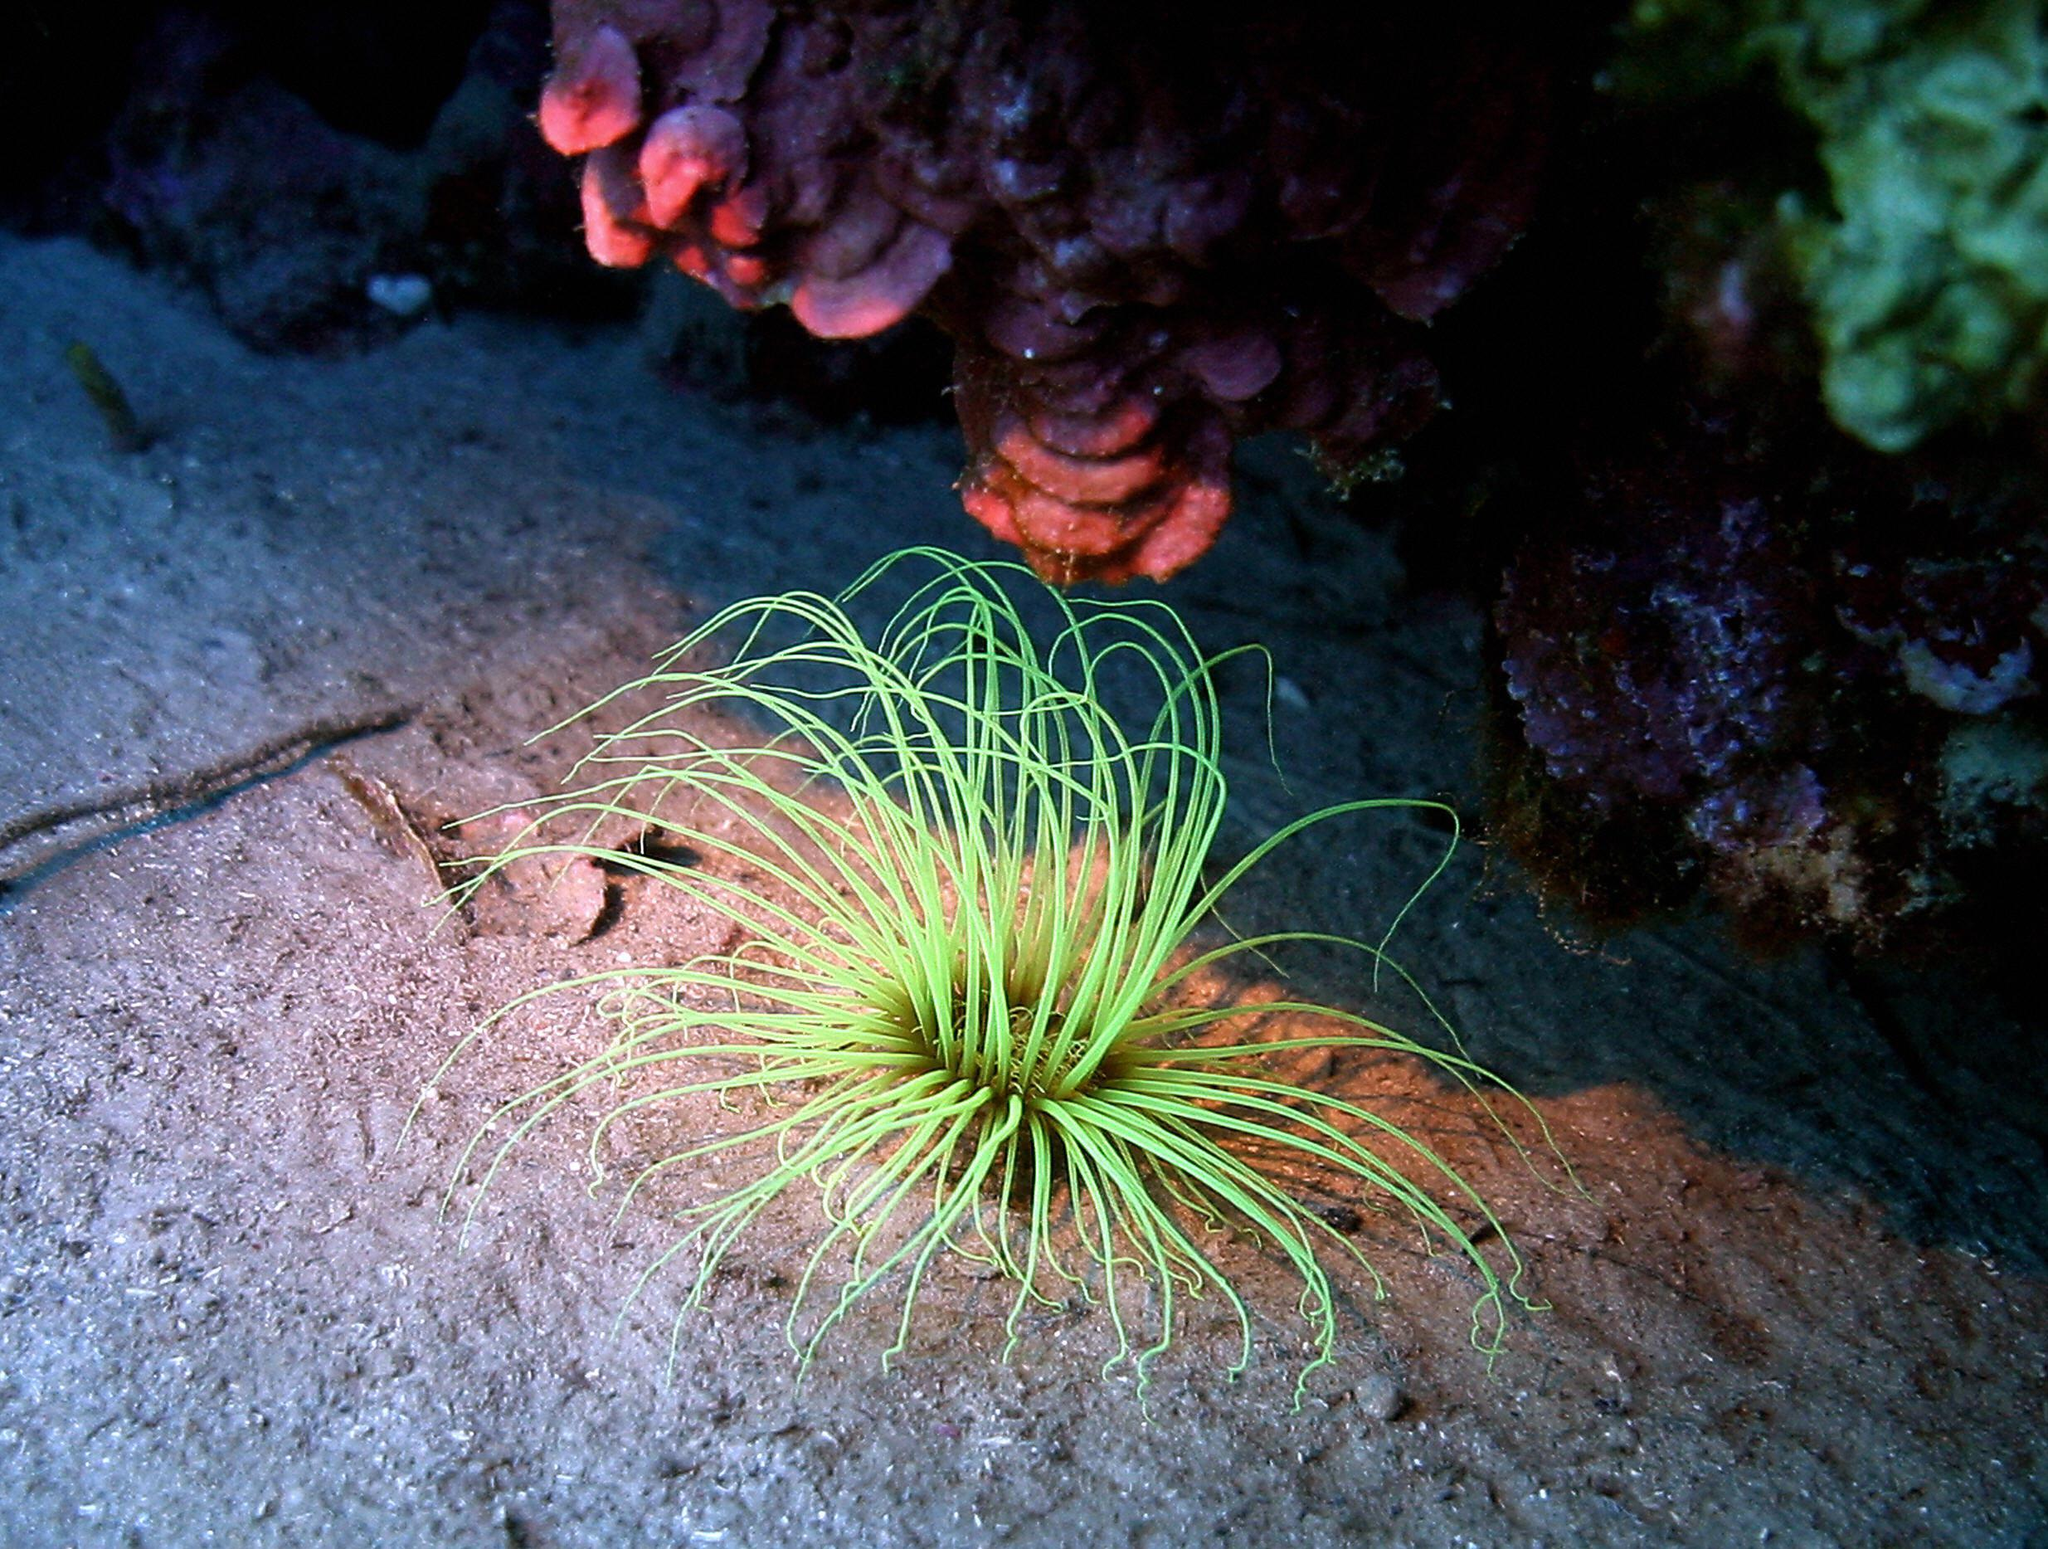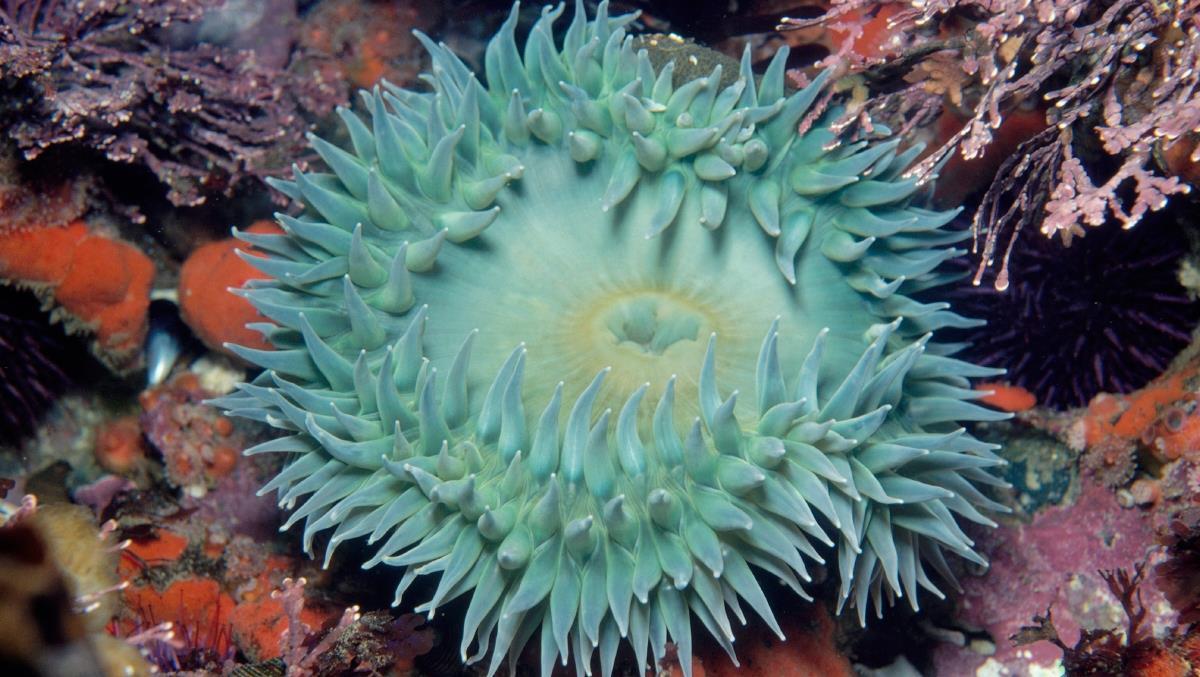The first image is the image on the left, the second image is the image on the right. Evaluate the accuracy of this statement regarding the images: "The creature in the image on the left has black and white markings.". Is it true? Answer yes or no. No. 